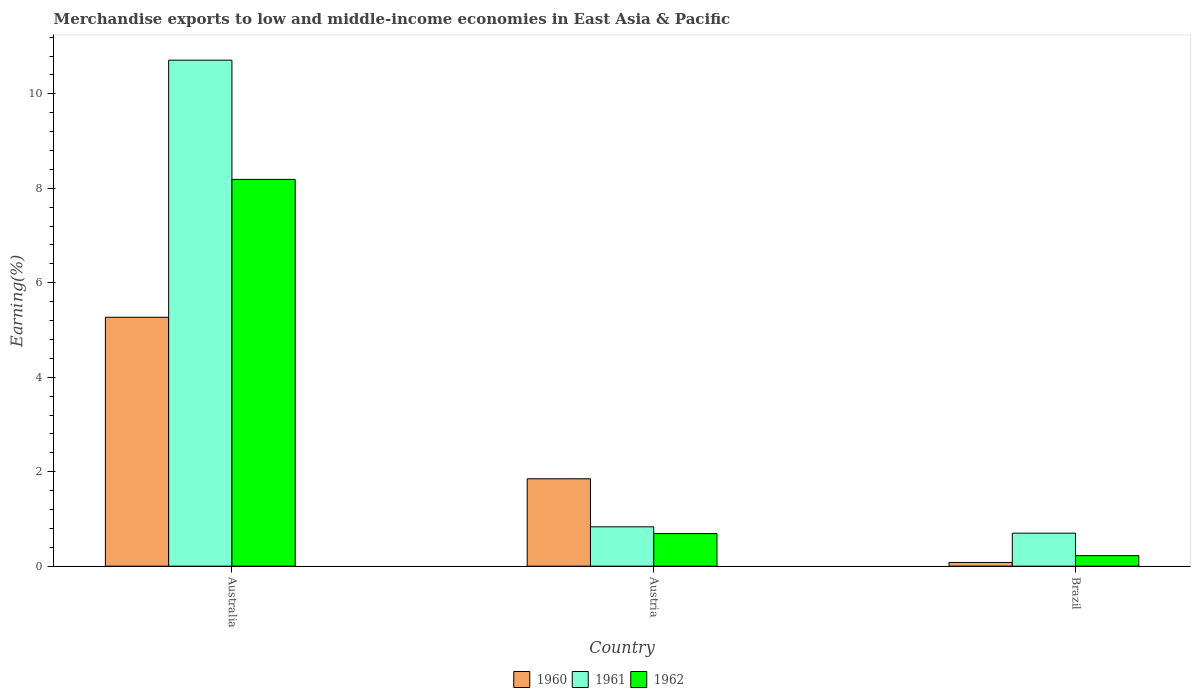How many different coloured bars are there?
Provide a short and direct response. 3. How many groups of bars are there?
Keep it short and to the point. 3. How many bars are there on the 2nd tick from the right?
Your response must be concise. 3. What is the label of the 2nd group of bars from the left?
Your answer should be compact. Austria. In how many cases, is the number of bars for a given country not equal to the number of legend labels?
Make the answer very short. 0. What is the percentage of amount earned from merchandise exports in 1962 in Austria?
Give a very brief answer. 0.69. Across all countries, what is the maximum percentage of amount earned from merchandise exports in 1962?
Provide a short and direct response. 8.19. Across all countries, what is the minimum percentage of amount earned from merchandise exports in 1960?
Make the answer very short. 0.08. In which country was the percentage of amount earned from merchandise exports in 1960 maximum?
Offer a terse response. Australia. What is the total percentage of amount earned from merchandise exports in 1961 in the graph?
Provide a succinct answer. 12.24. What is the difference between the percentage of amount earned from merchandise exports in 1961 in Australia and that in Austria?
Provide a succinct answer. 9.88. What is the difference between the percentage of amount earned from merchandise exports in 1962 in Austria and the percentage of amount earned from merchandise exports in 1961 in Australia?
Offer a terse response. -10.02. What is the average percentage of amount earned from merchandise exports in 1961 per country?
Provide a short and direct response. 4.08. What is the difference between the percentage of amount earned from merchandise exports of/in 1962 and percentage of amount earned from merchandise exports of/in 1961 in Austria?
Provide a short and direct response. -0.14. What is the ratio of the percentage of amount earned from merchandise exports in 1960 in Australia to that in Austria?
Provide a succinct answer. 2.85. Is the percentage of amount earned from merchandise exports in 1961 in Austria less than that in Brazil?
Your response must be concise. No. Is the difference between the percentage of amount earned from merchandise exports in 1962 in Australia and Brazil greater than the difference between the percentage of amount earned from merchandise exports in 1961 in Australia and Brazil?
Your answer should be very brief. No. What is the difference between the highest and the second highest percentage of amount earned from merchandise exports in 1962?
Your answer should be compact. 7.5. What is the difference between the highest and the lowest percentage of amount earned from merchandise exports in 1961?
Give a very brief answer. 10.01. In how many countries, is the percentage of amount earned from merchandise exports in 1961 greater than the average percentage of amount earned from merchandise exports in 1961 taken over all countries?
Ensure brevity in your answer.  1. What does the 2nd bar from the left in Australia represents?
Your response must be concise. 1961. What does the 3rd bar from the right in Austria represents?
Provide a succinct answer. 1960. Is it the case that in every country, the sum of the percentage of amount earned from merchandise exports in 1962 and percentage of amount earned from merchandise exports in 1960 is greater than the percentage of amount earned from merchandise exports in 1961?
Your answer should be very brief. No. How many countries are there in the graph?
Your answer should be compact. 3. What is the difference between two consecutive major ticks on the Y-axis?
Make the answer very short. 2. Are the values on the major ticks of Y-axis written in scientific E-notation?
Your answer should be very brief. No. How many legend labels are there?
Make the answer very short. 3. How are the legend labels stacked?
Offer a very short reply. Horizontal. What is the title of the graph?
Ensure brevity in your answer.  Merchandise exports to low and middle-income economies in East Asia & Pacific. What is the label or title of the X-axis?
Your response must be concise. Country. What is the label or title of the Y-axis?
Your response must be concise. Earning(%). What is the Earning(%) of 1960 in Australia?
Give a very brief answer. 5.27. What is the Earning(%) in 1961 in Australia?
Provide a succinct answer. 10.71. What is the Earning(%) in 1962 in Australia?
Your response must be concise. 8.19. What is the Earning(%) in 1960 in Austria?
Ensure brevity in your answer.  1.85. What is the Earning(%) in 1961 in Austria?
Offer a very short reply. 0.83. What is the Earning(%) of 1962 in Austria?
Your response must be concise. 0.69. What is the Earning(%) in 1960 in Brazil?
Your answer should be very brief. 0.08. What is the Earning(%) in 1961 in Brazil?
Keep it short and to the point. 0.7. What is the Earning(%) in 1962 in Brazil?
Your response must be concise. 0.22. Across all countries, what is the maximum Earning(%) in 1960?
Give a very brief answer. 5.27. Across all countries, what is the maximum Earning(%) of 1961?
Your answer should be very brief. 10.71. Across all countries, what is the maximum Earning(%) in 1962?
Your answer should be compact. 8.19. Across all countries, what is the minimum Earning(%) in 1960?
Provide a short and direct response. 0.08. Across all countries, what is the minimum Earning(%) in 1961?
Your answer should be compact. 0.7. Across all countries, what is the minimum Earning(%) of 1962?
Your response must be concise. 0.22. What is the total Earning(%) in 1960 in the graph?
Your response must be concise. 7.2. What is the total Earning(%) of 1961 in the graph?
Give a very brief answer. 12.24. What is the total Earning(%) of 1962 in the graph?
Provide a short and direct response. 9.1. What is the difference between the Earning(%) of 1960 in Australia and that in Austria?
Your answer should be compact. 3.42. What is the difference between the Earning(%) in 1961 in Australia and that in Austria?
Offer a very short reply. 9.88. What is the difference between the Earning(%) of 1962 in Australia and that in Austria?
Keep it short and to the point. 7.5. What is the difference between the Earning(%) in 1960 in Australia and that in Brazil?
Keep it short and to the point. 5.19. What is the difference between the Earning(%) in 1961 in Australia and that in Brazil?
Your answer should be very brief. 10.01. What is the difference between the Earning(%) of 1962 in Australia and that in Brazil?
Provide a succinct answer. 7.97. What is the difference between the Earning(%) in 1960 in Austria and that in Brazil?
Ensure brevity in your answer.  1.77. What is the difference between the Earning(%) of 1961 in Austria and that in Brazil?
Give a very brief answer. 0.13. What is the difference between the Earning(%) of 1962 in Austria and that in Brazil?
Offer a very short reply. 0.47. What is the difference between the Earning(%) of 1960 in Australia and the Earning(%) of 1961 in Austria?
Your answer should be very brief. 4.44. What is the difference between the Earning(%) of 1960 in Australia and the Earning(%) of 1962 in Austria?
Offer a terse response. 4.58. What is the difference between the Earning(%) of 1961 in Australia and the Earning(%) of 1962 in Austria?
Give a very brief answer. 10.02. What is the difference between the Earning(%) in 1960 in Australia and the Earning(%) in 1961 in Brazil?
Offer a terse response. 4.57. What is the difference between the Earning(%) of 1960 in Australia and the Earning(%) of 1962 in Brazil?
Offer a terse response. 5.05. What is the difference between the Earning(%) of 1961 in Australia and the Earning(%) of 1962 in Brazil?
Ensure brevity in your answer.  10.49. What is the difference between the Earning(%) of 1960 in Austria and the Earning(%) of 1961 in Brazil?
Ensure brevity in your answer.  1.15. What is the difference between the Earning(%) of 1960 in Austria and the Earning(%) of 1962 in Brazil?
Your response must be concise. 1.63. What is the difference between the Earning(%) of 1961 in Austria and the Earning(%) of 1962 in Brazil?
Offer a very short reply. 0.61. What is the average Earning(%) in 1960 per country?
Offer a terse response. 2.4. What is the average Earning(%) in 1961 per country?
Offer a very short reply. 4.08. What is the average Earning(%) of 1962 per country?
Offer a very short reply. 3.03. What is the difference between the Earning(%) of 1960 and Earning(%) of 1961 in Australia?
Offer a terse response. -5.44. What is the difference between the Earning(%) of 1960 and Earning(%) of 1962 in Australia?
Your answer should be very brief. -2.92. What is the difference between the Earning(%) in 1961 and Earning(%) in 1962 in Australia?
Your answer should be compact. 2.52. What is the difference between the Earning(%) of 1960 and Earning(%) of 1961 in Austria?
Offer a very short reply. 1.02. What is the difference between the Earning(%) of 1960 and Earning(%) of 1962 in Austria?
Offer a very short reply. 1.16. What is the difference between the Earning(%) of 1961 and Earning(%) of 1962 in Austria?
Offer a terse response. 0.14. What is the difference between the Earning(%) of 1960 and Earning(%) of 1961 in Brazil?
Keep it short and to the point. -0.62. What is the difference between the Earning(%) in 1960 and Earning(%) in 1962 in Brazil?
Your answer should be very brief. -0.14. What is the difference between the Earning(%) of 1961 and Earning(%) of 1962 in Brazil?
Offer a very short reply. 0.48. What is the ratio of the Earning(%) of 1960 in Australia to that in Austria?
Provide a short and direct response. 2.85. What is the ratio of the Earning(%) of 1961 in Australia to that in Austria?
Keep it short and to the point. 12.85. What is the ratio of the Earning(%) of 1962 in Australia to that in Austria?
Offer a terse response. 11.87. What is the ratio of the Earning(%) in 1960 in Australia to that in Brazil?
Make the answer very short. 66.92. What is the ratio of the Earning(%) of 1961 in Australia to that in Brazil?
Offer a terse response. 15.33. What is the ratio of the Earning(%) in 1962 in Australia to that in Brazil?
Your answer should be very brief. 36.8. What is the ratio of the Earning(%) in 1960 in Austria to that in Brazil?
Ensure brevity in your answer.  23.49. What is the ratio of the Earning(%) in 1961 in Austria to that in Brazil?
Your answer should be very brief. 1.19. What is the ratio of the Earning(%) in 1962 in Austria to that in Brazil?
Ensure brevity in your answer.  3.1. What is the difference between the highest and the second highest Earning(%) of 1960?
Ensure brevity in your answer.  3.42. What is the difference between the highest and the second highest Earning(%) in 1961?
Keep it short and to the point. 9.88. What is the difference between the highest and the second highest Earning(%) in 1962?
Your response must be concise. 7.5. What is the difference between the highest and the lowest Earning(%) in 1960?
Provide a short and direct response. 5.19. What is the difference between the highest and the lowest Earning(%) in 1961?
Offer a very short reply. 10.01. What is the difference between the highest and the lowest Earning(%) of 1962?
Your answer should be very brief. 7.97. 